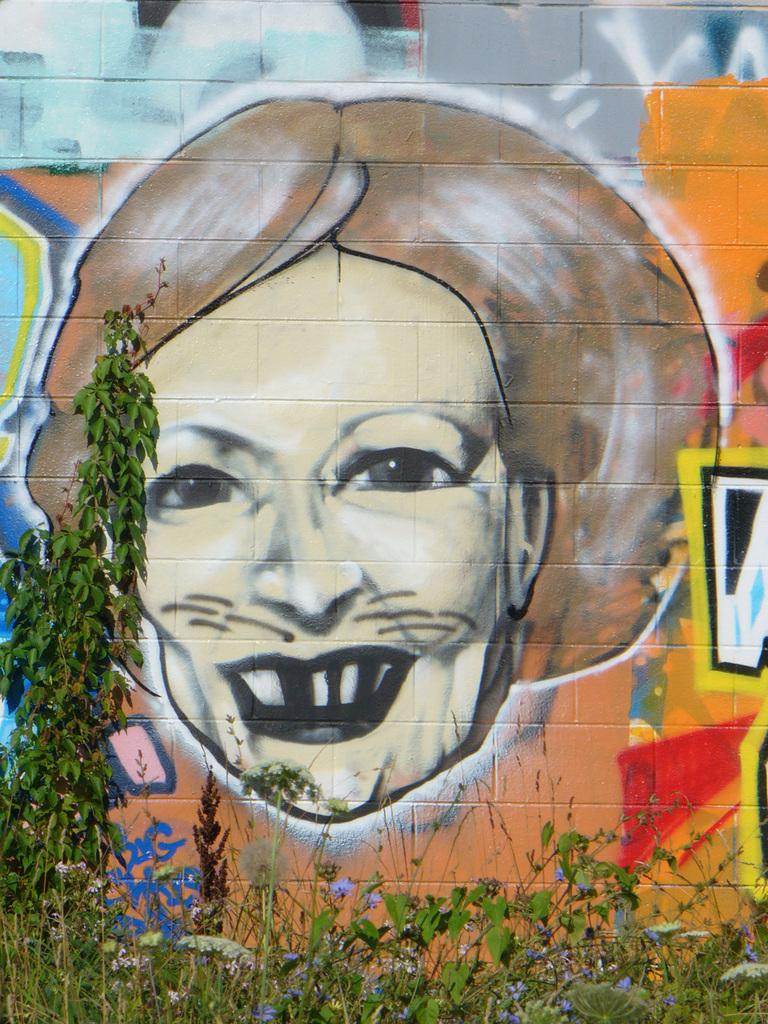What is present on the wall in the image? There is graffiti on the wall in the image. What else can be seen at the bottom of the wall? There are plants at the bottom of the wall. Can you describe the wall in the image? The wall has graffiti on it and is accompanied by plants at the bottom. How many ants can be seen crawling on the graffiti in the image? There are no ants present in the image. What type of curve is visible in the graffiti in the image? There is no curve visible in the graffiti in the image. 